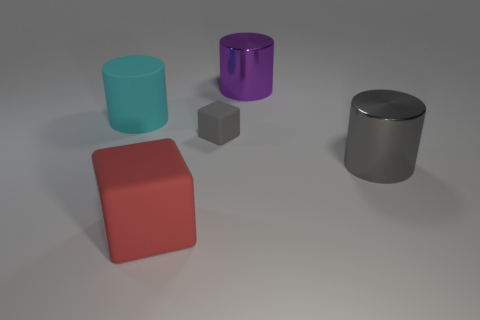What shape is the big metal thing that is the same color as the tiny object?
Keep it short and to the point. Cylinder. What number of cubes are either big cyan rubber things or purple objects?
Provide a short and direct response. 0. Is the number of cyan matte objects that are in front of the cyan rubber object the same as the number of red things behind the tiny gray rubber object?
Provide a succinct answer. Yes. There is a red rubber thing that is the same shape as the tiny gray thing; what is its size?
Ensure brevity in your answer.  Large. How big is the thing that is both on the left side of the gray matte block and in front of the large cyan rubber object?
Your response must be concise. Large. There is a gray cube; are there any big cubes behind it?
Make the answer very short. No. How many things are either matte blocks that are left of the gray matte object or tiny gray matte cubes?
Your response must be concise. 2. How many gray metal cylinders are behind the large shiny cylinder behind the cyan thing?
Provide a succinct answer. 0. Are there fewer cyan matte objects in front of the cyan object than rubber objects in front of the small gray rubber cube?
Offer a very short reply. Yes. There is a thing that is behind the big cylinder on the left side of the purple cylinder; what shape is it?
Give a very brief answer. Cylinder. 